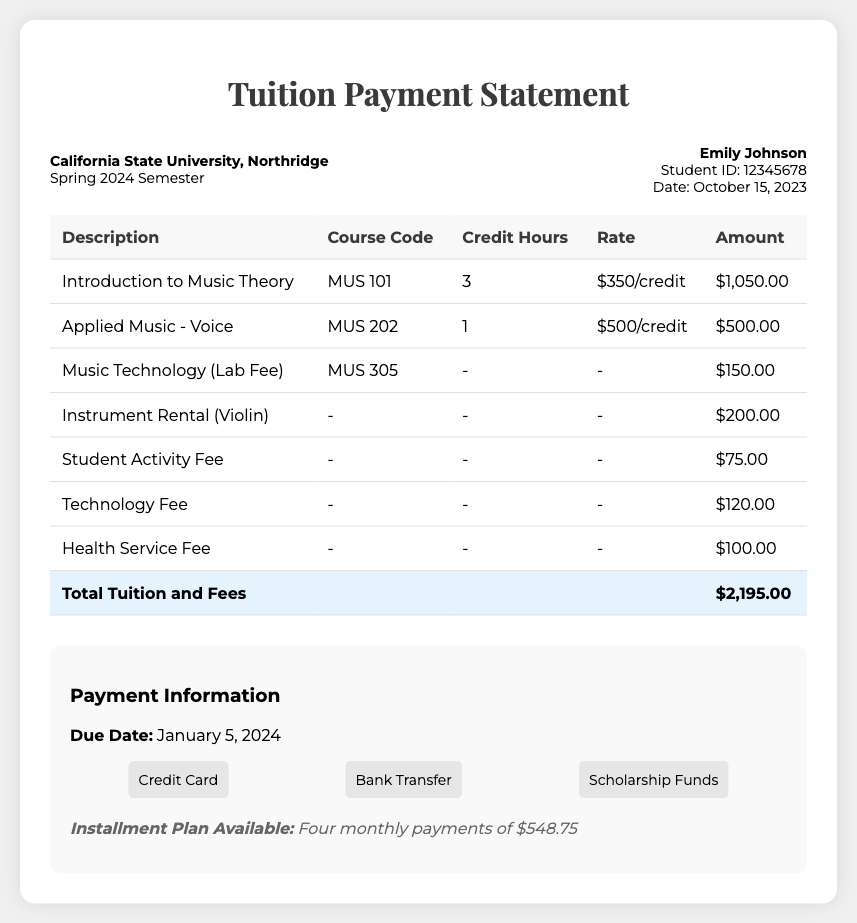What is the total tuition and fees for the semester? The total tuition and fees are listed at the bottom of the charges table, totaling $2,195.00.
Answer: $2,195.00 What is the due date for payment? The due date is specified in the payment information section of the document as January 5, 2024.
Answer: January 5, 2024 What course code corresponds to the "Applied Music - Voice" class? The course code for "Applied Music - Voice" is found in the charges table, listed as MUS 202.
Answer: MUS 202 How many credit hours are required for "Introduction to Music Theory"? The credit hours for "Introduction to Music Theory" can be found in the charges table and are stated as 3 hours.
Answer: 3 What is the amount charged for the "Instrument Rental (Violin)"? The amount charged for the "Instrument Rental (Violin)" is specified in the charges table as $200.00.
Answer: $200.00 What is the rate per credit hour for "Applied Music - Voice"? The rate is listed in the charges table under the rate column and is $500 per credit hour.
Answer: $500/credit What is included in the installment plan? The installment plan details a payment option that breaks the total into four monthly payments of $548.75.
Answer: Four monthly payments of $548.75 What is the student’s name? The student's name is presented in the student info section of the document as Emily Johnson.
Answer: Emily Johnson What is the lab fee for Music Technology? The lab fee for Music Technology is indicated in the charges table as $150.00.
Answer: $150.00 